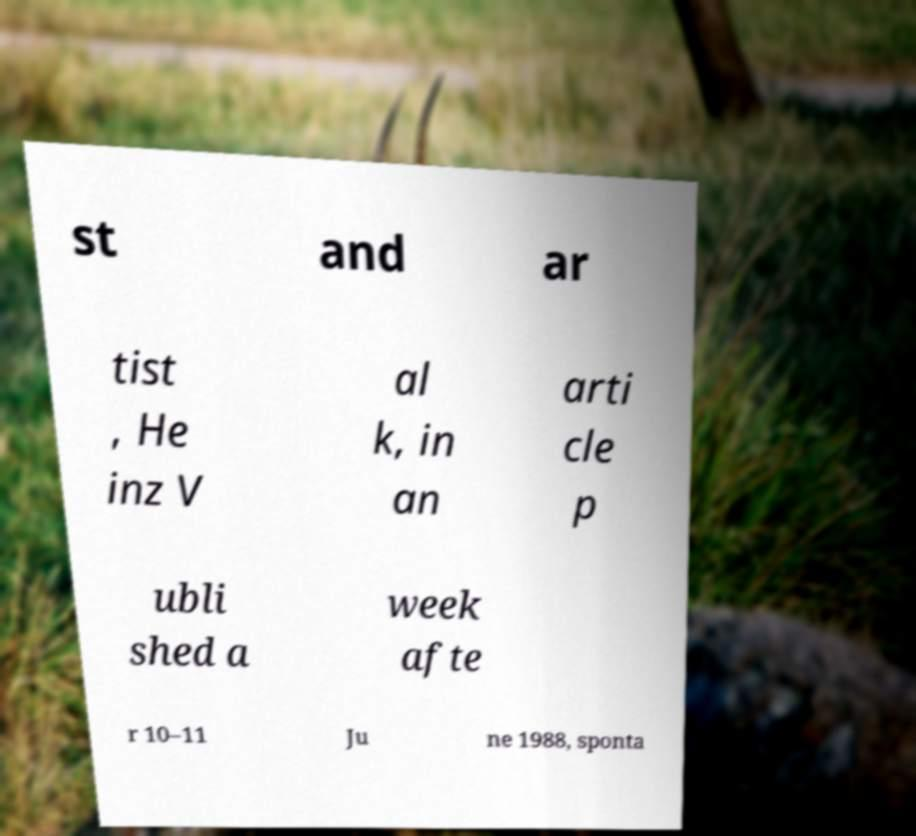Please read and relay the text visible in this image. What does it say? st and ar tist , He inz V al k, in an arti cle p ubli shed a week afte r 10–11 Ju ne 1988, sponta 